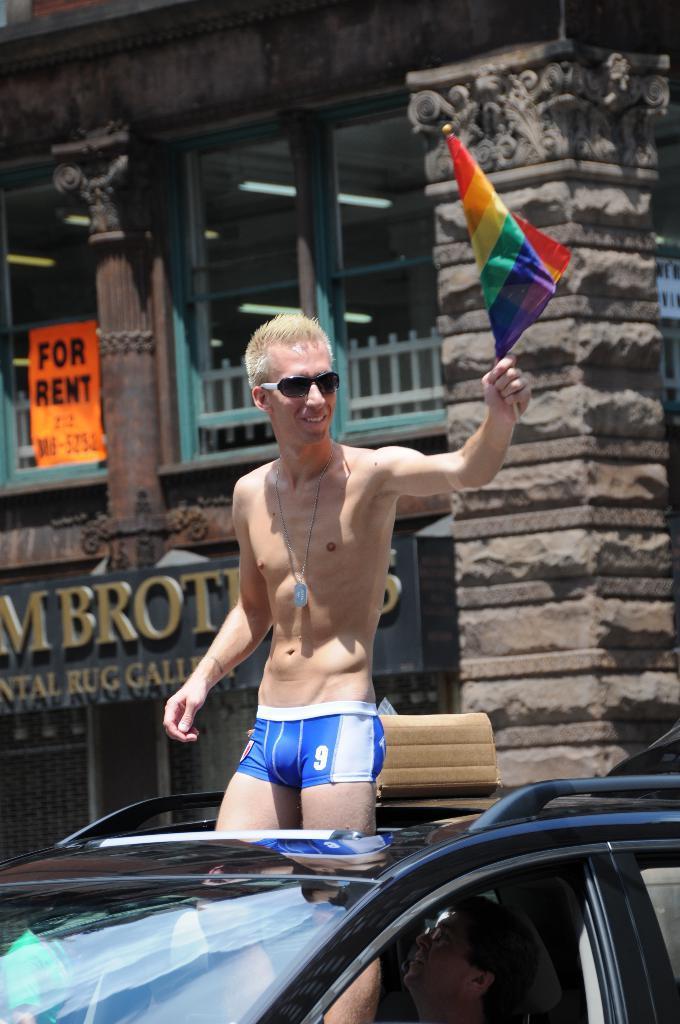Could you give a brief overview of what you see in this image? In this image i can see a person wearing glasses and holding a flag in his hand standing in a car, and i can see a person sitting in the driver seat of the car. In the background i can see few board, a building and a pillar. 